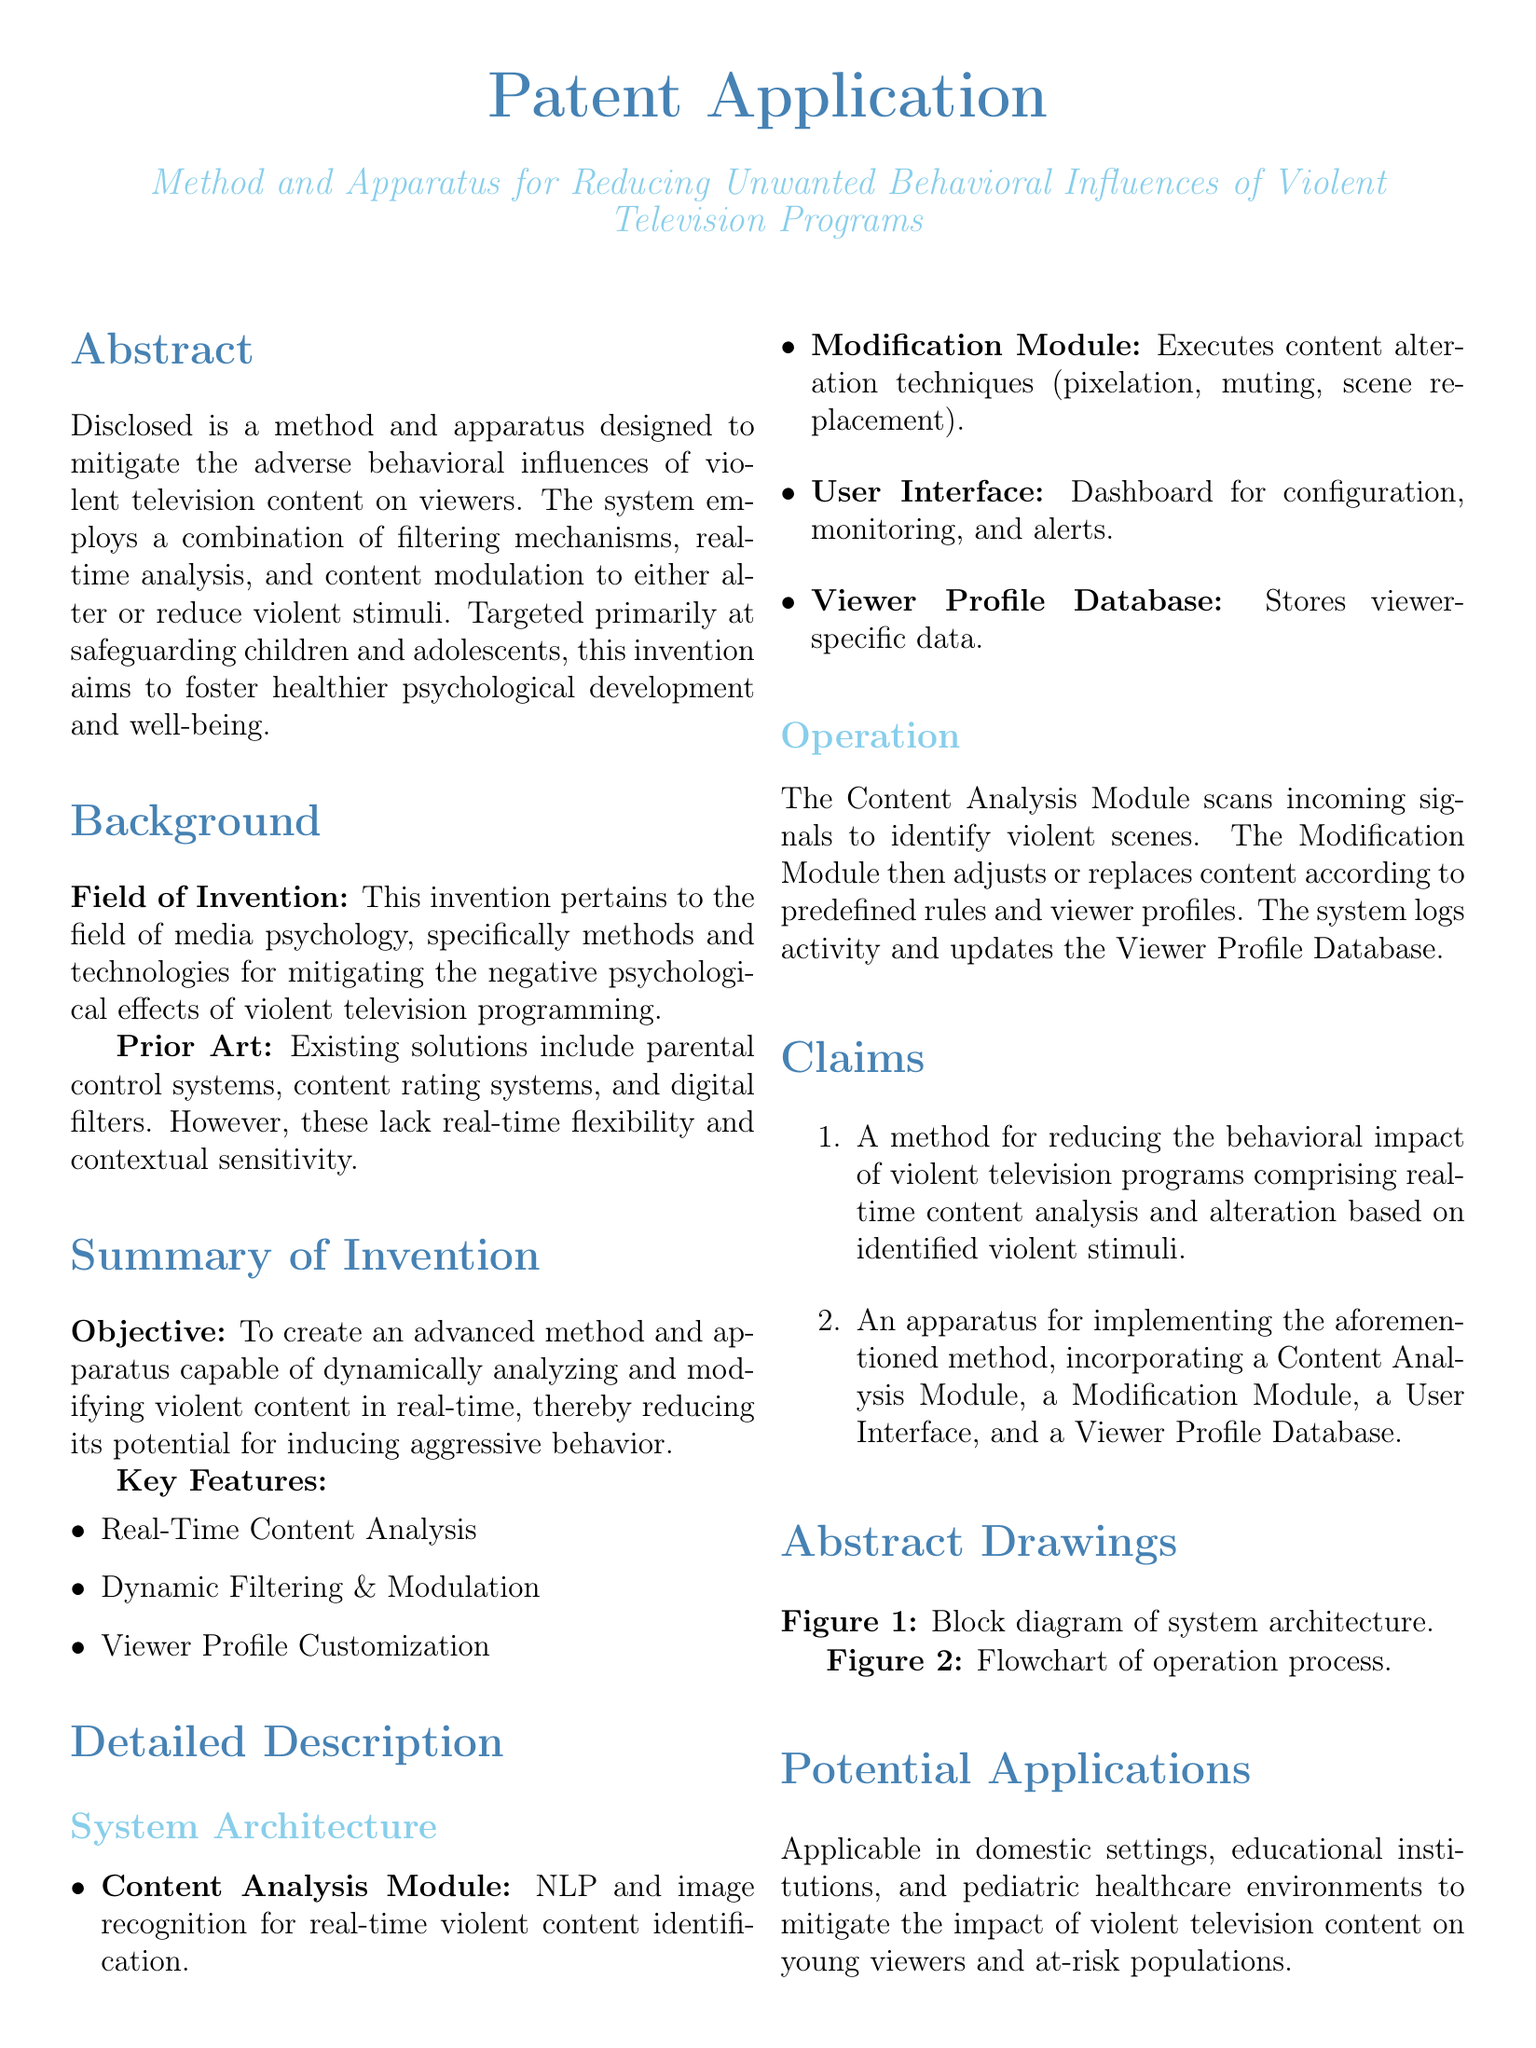What is the main objective of the invention? The objective is to create an advanced method and apparatus capable of dynamically analyzing and modifying violent content in real-time.
Answer: Dynamic analysis and modification of violent content What technology does the Content Analysis Module use for identifying violent content? The Content Analysis Module uses NLP and image recognition for real-time violent content identification.
Answer: NLP and image recognition What are the key features of the invention? The key features include Real-Time Content Analysis, Dynamic Filtering & Modulation, and Viewer Profile Customization.
Answer: Real-Time Content Analysis, Dynamic Filtering & Modulation, Viewer Profile Customization How many claims are included in the patent? The number of claims is stated in the Claims section of the document.
Answer: Two In which settings can the invention be applied? The potential applications mentioned include domestic settings, educational institutions, and pediatric healthcare environments.
Answer: Domestic settings, educational institutions, pediatric healthcare What does the Modification Module do? The Modification Module executes content alteration techniques such as pixelation, muting, and scene replacement.
Answer: Executes content alteration techniques What is the field of invention? The field of invention pertains to media psychology.
Answer: Media psychology What is the purpose of the Viewer Profile Database? The Viewer Profile Database stores viewer-specific data.
Answer: Stores viewer-specific data 